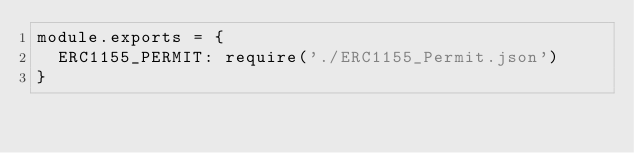<code> <loc_0><loc_0><loc_500><loc_500><_JavaScript_>module.exports = {
  ERC1155_PERMIT: require('./ERC1155_Permit.json')
}</code> 